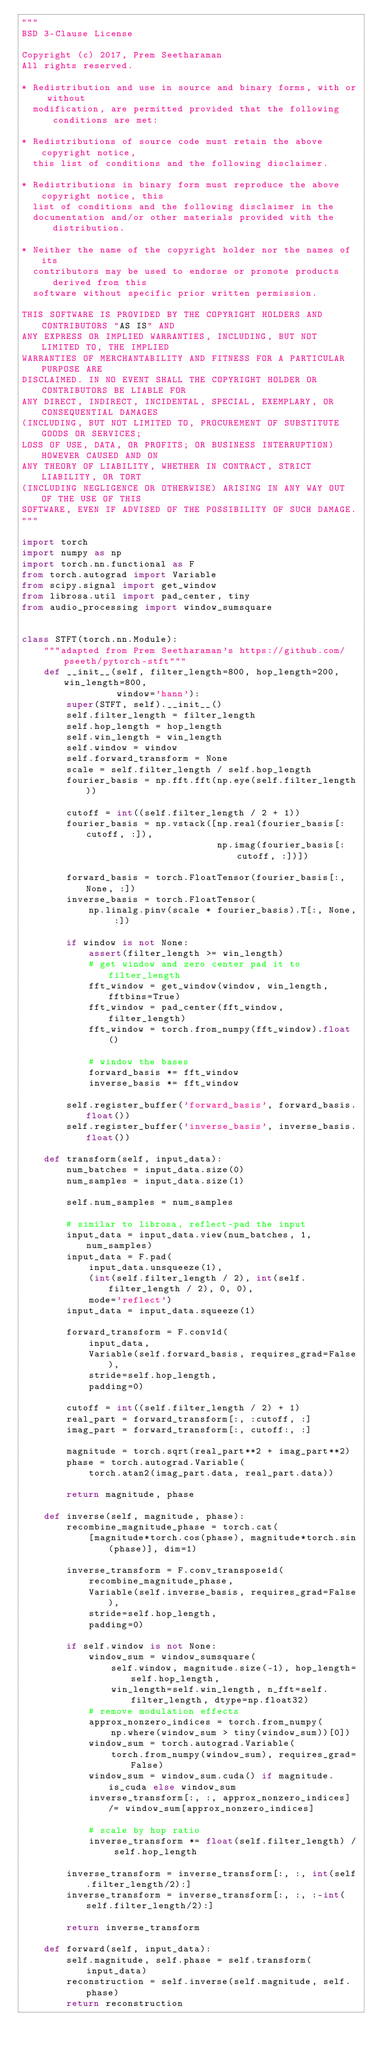Convert code to text. <code><loc_0><loc_0><loc_500><loc_500><_Python_>"""
BSD 3-Clause License

Copyright (c) 2017, Prem Seetharaman
All rights reserved.

* Redistribution and use in source and binary forms, with or without
  modification, are permitted provided that the following conditions are met:

* Redistributions of source code must retain the above copyright notice,
  this list of conditions and the following disclaimer.

* Redistributions in binary form must reproduce the above copyright notice, this
  list of conditions and the following disclaimer in the
  documentation and/or other materials provided with the distribution.

* Neither the name of the copyright holder nor the names of its
  contributors may be used to endorse or promote products derived from this
  software without specific prior written permission.

THIS SOFTWARE IS PROVIDED BY THE COPYRIGHT HOLDERS AND CONTRIBUTORS "AS IS" AND
ANY EXPRESS OR IMPLIED WARRANTIES, INCLUDING, BUT NOT LIMITED TO, THE IMPLIED
WARRANTIES OF MERCHANTABILITY AND FITNESS FOR A PARTICULAR PURPOSE ARE
DISCLAIMED. IN NO EVENT SHALL THE COPYRIGHT HOLDER OR CONTRIBUTORS BE LIABLE FOR
ANY DIRECT, INDIRECT, INCIDENTAL, SPECIAL, EXEMPLARY, OR CONSEQUENTIAL DAMAGES
(INCLUDING, BUT NOT LIMITED TO, PROCUREMENT OF SUBSTITUTE GOODS OR SERVICES;
LOSS OF USE, DATA, OR PROFITS; OR BUSINESS INTERRUPTION) HOWEVER CAUSED AND ON
ANY THEORY OF LIABILITY, WHETHER IN CONTRACT, STRICT LIABILITY, OR TORT
(INCLUDING NEGLIGENCE OR OTHERWISE) ARISING IN ANY WAY OUT OF THE USE OF THIS
SOFTWARE, EVEN IF ADVISED OF THE POSSIBILITY OF SUCH DAMAGE.
"""

import torch
import numpy as np
import torch.nn.functional as F
from torch.autograd import Variable
from scipy.signal import get_window
from librosa.util import pad_center, tiny
from audio_processing import window_sumsquare


class STFT(torch.nn.Module):
    """adapted from Prem Seetharaman's https://github.com/pseeth/pytorch-stft"""
    def __init__(self, filter_length=800, hop_length=200, win_length=800,
                 window='hann'):
        super(STFT, self).__init__()
        self.filter_length = filter_length
        self.hop_length = hop_length
        self.win_length = win_length
        self.window = window
        self.forward_transform = None
        scale = self.filter_length / self.hop_length
        fourier_basis = np.fft.fft(np.eye(self.filter_length))

        cutoff = int((self.filter_length / 2 + 1))
        fourier_basis = np.vstack([np.real(fourier_basis[:cutoff, :]),
                                   np.imag(fourier_basis[:cutoff, :])])

        forward_basis = torch.FloatTensor(fourier_basis[:, None, :])
        inverse_basis = torch.FloatTensor(
            np.linalg.pinv(scale * fourier_basis).T[:, None, :])

        if window is not None:
            assert(filter_length >= win_length)
            # get window and zero center pad it to filter_length
            fft_window = get_window(window, win_length, fftbins=True)
            fft_window = pad_center(fft_window, filter_length)
            fft_window = torch.from_numpy(fft_window).float()

            # window the bases
            forward_basis *= fft_window
            inverse_basis *= fft_window

        self.register_buffer('forward_basis', forward_basis.float())
        self.register_buffer('inverse_basis', inverse_basis.float())

    def transform(self, input_data):
        num_batches = input_data.size(0)
        num_samples = input_data.size(1)

        self.num_samples = num_samples

        # similar to librosa, reflect-pad the input
        input_data = input_data.view(num_batches, 1, num_samples)
        input_data = F.pad(
            input_data.unsqueeze(1),
            (int(self.filter_length / 2), int(self.filter_length / 2), 0, 0),
            mode='reflect')
        input_data = input_data.squeeze(1)

        forward_transform = F.conv1d(
            input_data,
            Variable(self.forward_basis, requires_grad=False),
            stride=self.hop_length,
            padding=0)

        cutoff = int((self.filter_length / 2) + 1)
        real_part = forward_transform[:, :cutoff, :]
        imag_part = forward_transform[:, cutoff:, :]

        magnitude = torch.sqrt(real_part**2 + imag_part**2)
        phase = torch.autograd.Variable(
            torch.atan2(imag_part.data, real_part.data))

        return magnitude, phase

    def inverse(self, magnitude, phase):
        recombine_magnitude_phase = torch.cat(
            [magnitude*torch.cos(phase), magnitude*torch.sin(phase)], dim=1)

        inverse_transform = F.conv_transpose1d(
            recombine_magnitude_phase,
            Variable(self.inverse_basis, requires_grad=False),
            stride=self.hop_length,
            padding=0)

        if self.window is not None:
            window_sum = window_sumsquare(
                self.window, magnitude.size(-1), hop_length=self.hop_length,
                win_length=self.win_length, n_fft=self.filter_length, dtype=np.float32)
            # remove modulation effects
            approx_nonzero_indices = torch.from_numpy(
                np.where(window_sum > tiny(window_sum))[0])
            window_sum = torch.autograd.Variable(
                torch.from_numpy(window_sum), requires_grad=False)
            window_sum = window_sum.cuda() if magnitude.is_cuda else window_sum
            inverse_transform[:, :, approx_nonzero_indices] /= window_sum[approx_nonzero_indices]

            # scale by hop ratio
            inverse_transform *= float(self.filter_length) / self.hop_length

        inverse_transform = inverse_transform[:, :, int(self.filter_length/2):]
        inverse_transform = inverse_transform[:, :, :-int(self.filter_length/2):]

        return inverse_transform

    def forward(self, input_data):
        self.magnitude, self.phase = self.transform(input_data)
        reconstruction = self.inverse(self.magnitude, self.phase)
        return reconstruction
</code> 